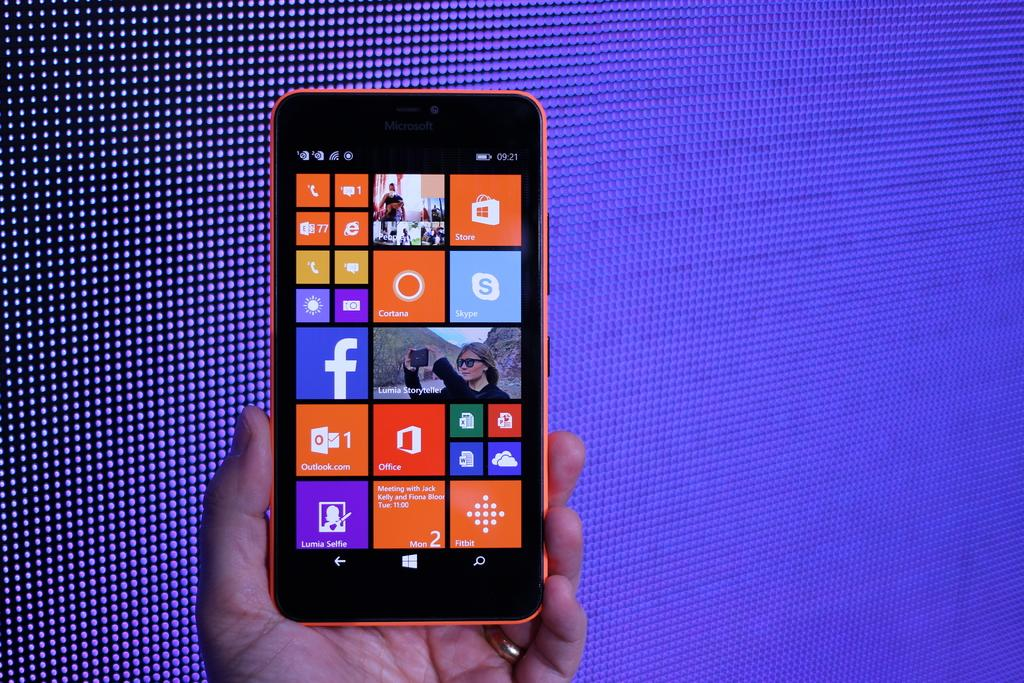<image>
Create a compact narrative representing the image presented. A phone screen showing a variety of apps including Skype. 